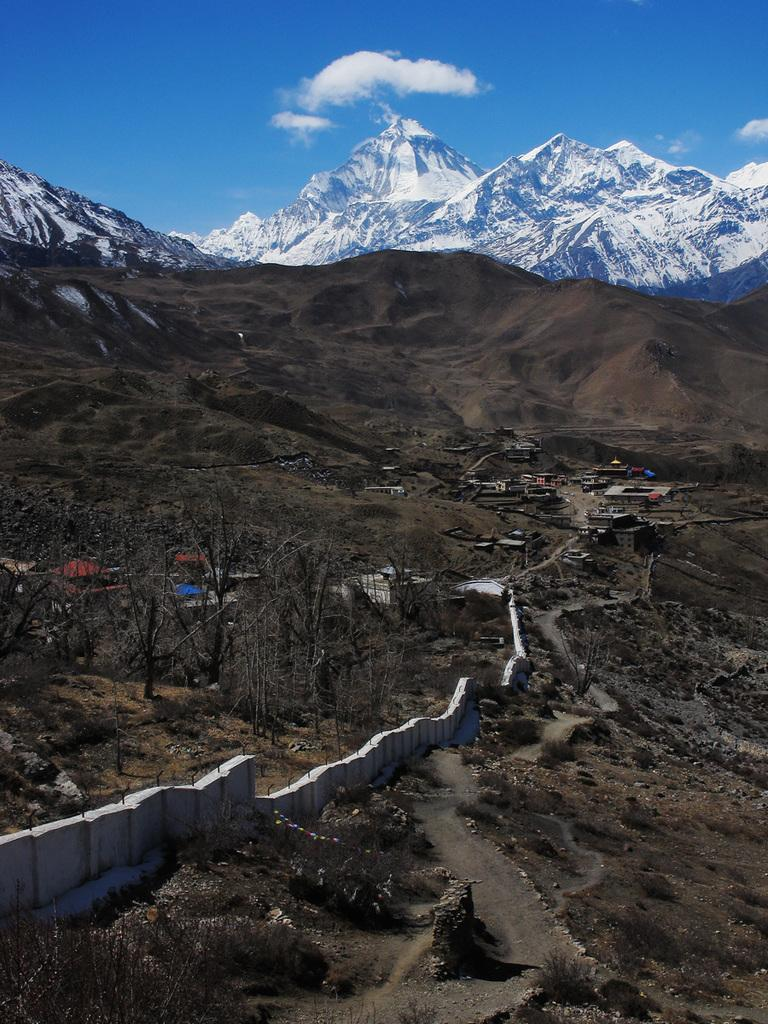What is one of the main features in the image? There is a wall in the image. What type of natural elements can be seen in the image? There are many trees in the image. What can be seen in the distance in the image? There are buildings and hills in the background of the image. What is the weather like in the image? There is snow visible in the image, and the sky with clouds is visible. Where is the fireman putting out the fire in the image? There is no fireman or fire present in the image. What color is the father's sock in the image? There is no father or sock present in the image. 